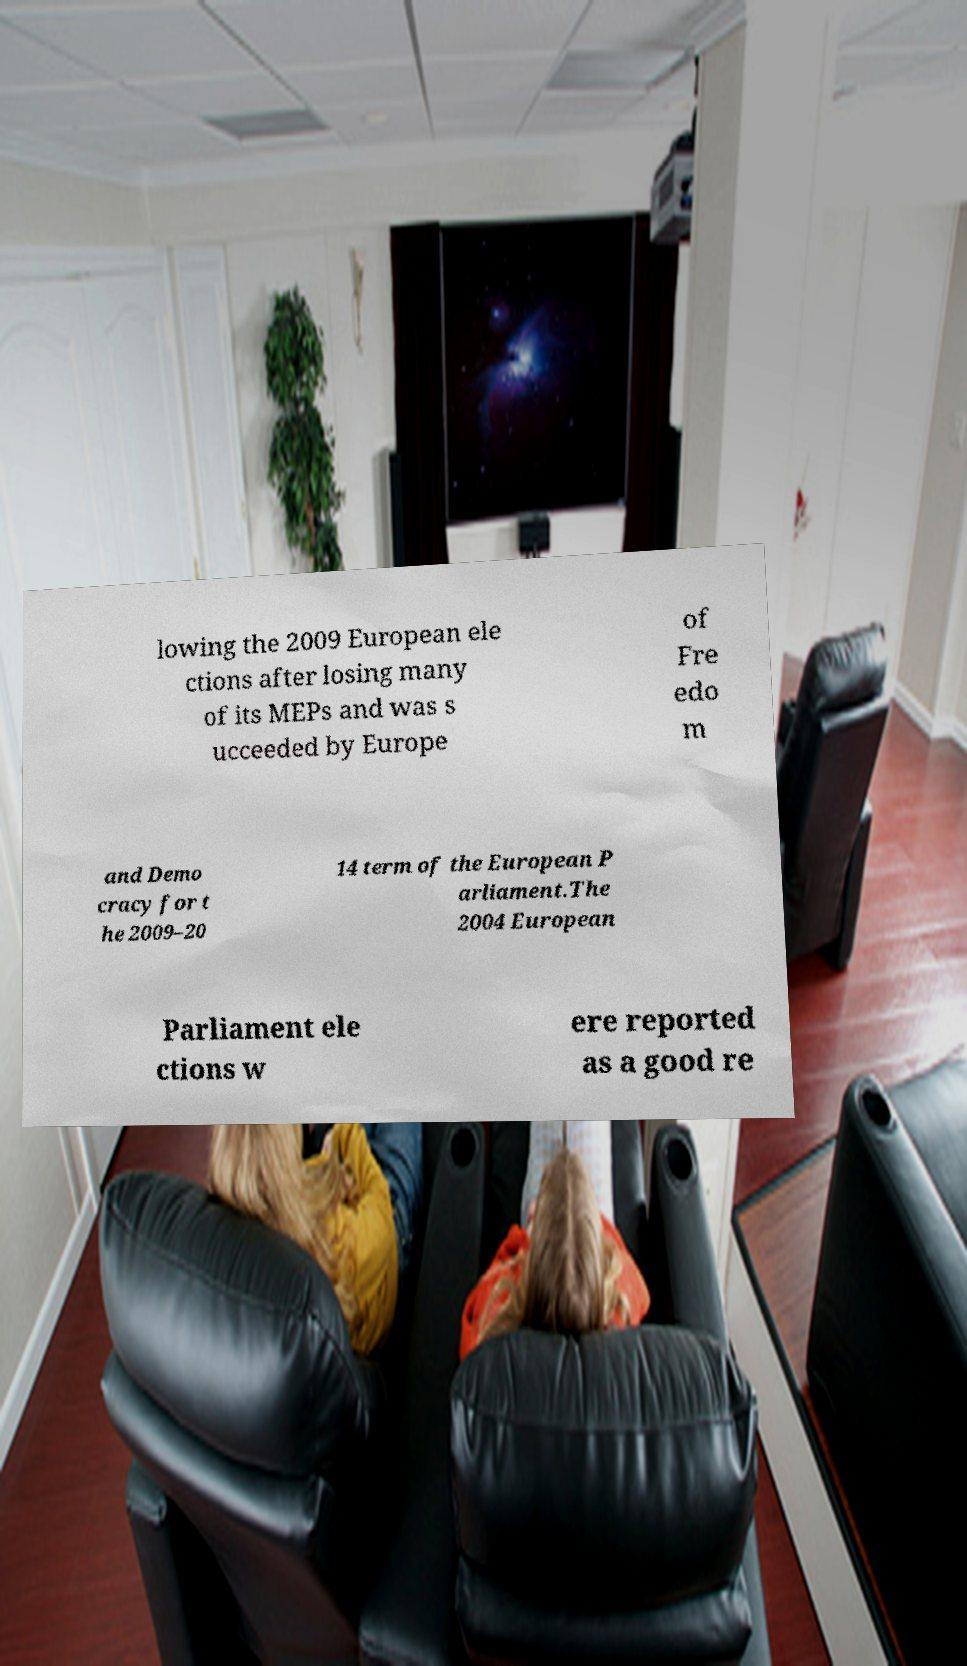Can you accurately transcribe the text from the provided image for me? lowing the 2009 European ele ctions after losing many of its MEPs and was s ucceeded by Europe of Fre edo m and Demo cracy for t he 2009–20 14 term of the European P arliament.The 2004 European Parliament ele ctions w ere reported as a good re 